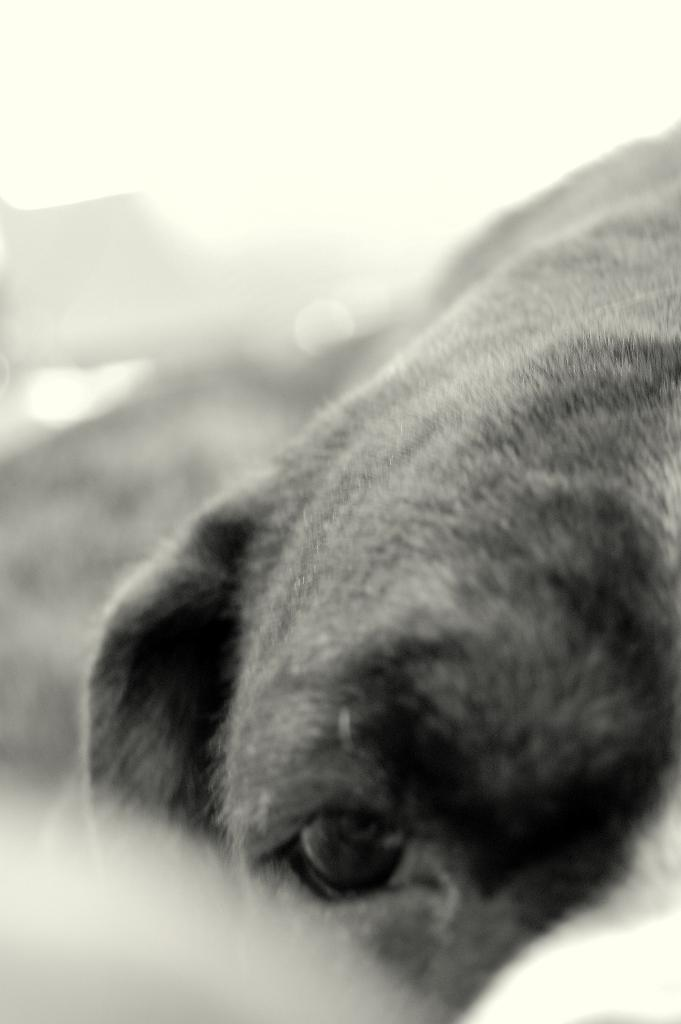What is the main subject in the foreground of the image? There is an animal in the foreground of the image. Can you describe the background of the image? The background of the image is blurred. How does the animal in the image believe in the concept of coughing? The image does not provide any information about the animal's beliefs or the concept of coughing, so it cannot be determined from the image. 